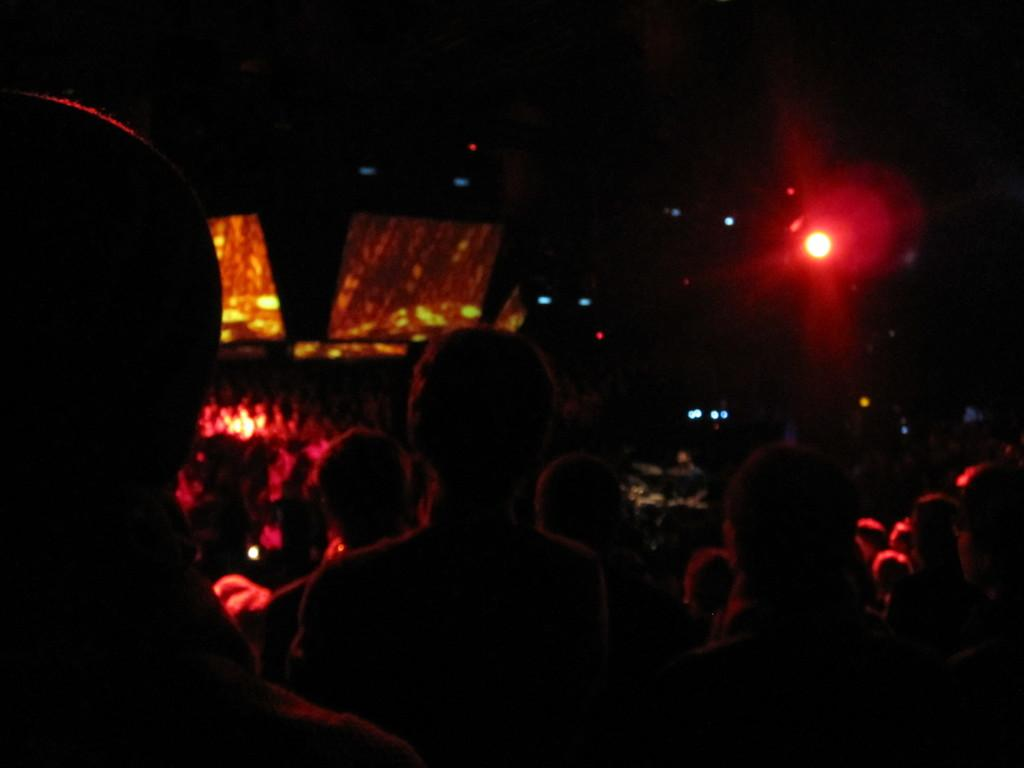Who or what can be seen in the image? There are people in the image. What else is present in the image besides the people? There are lights in the image. Can you describe the background of the image? The background of the image is dark. What type of root can be seen growing in the image? There is no root present in the image; it features people and lights with a dark background. 